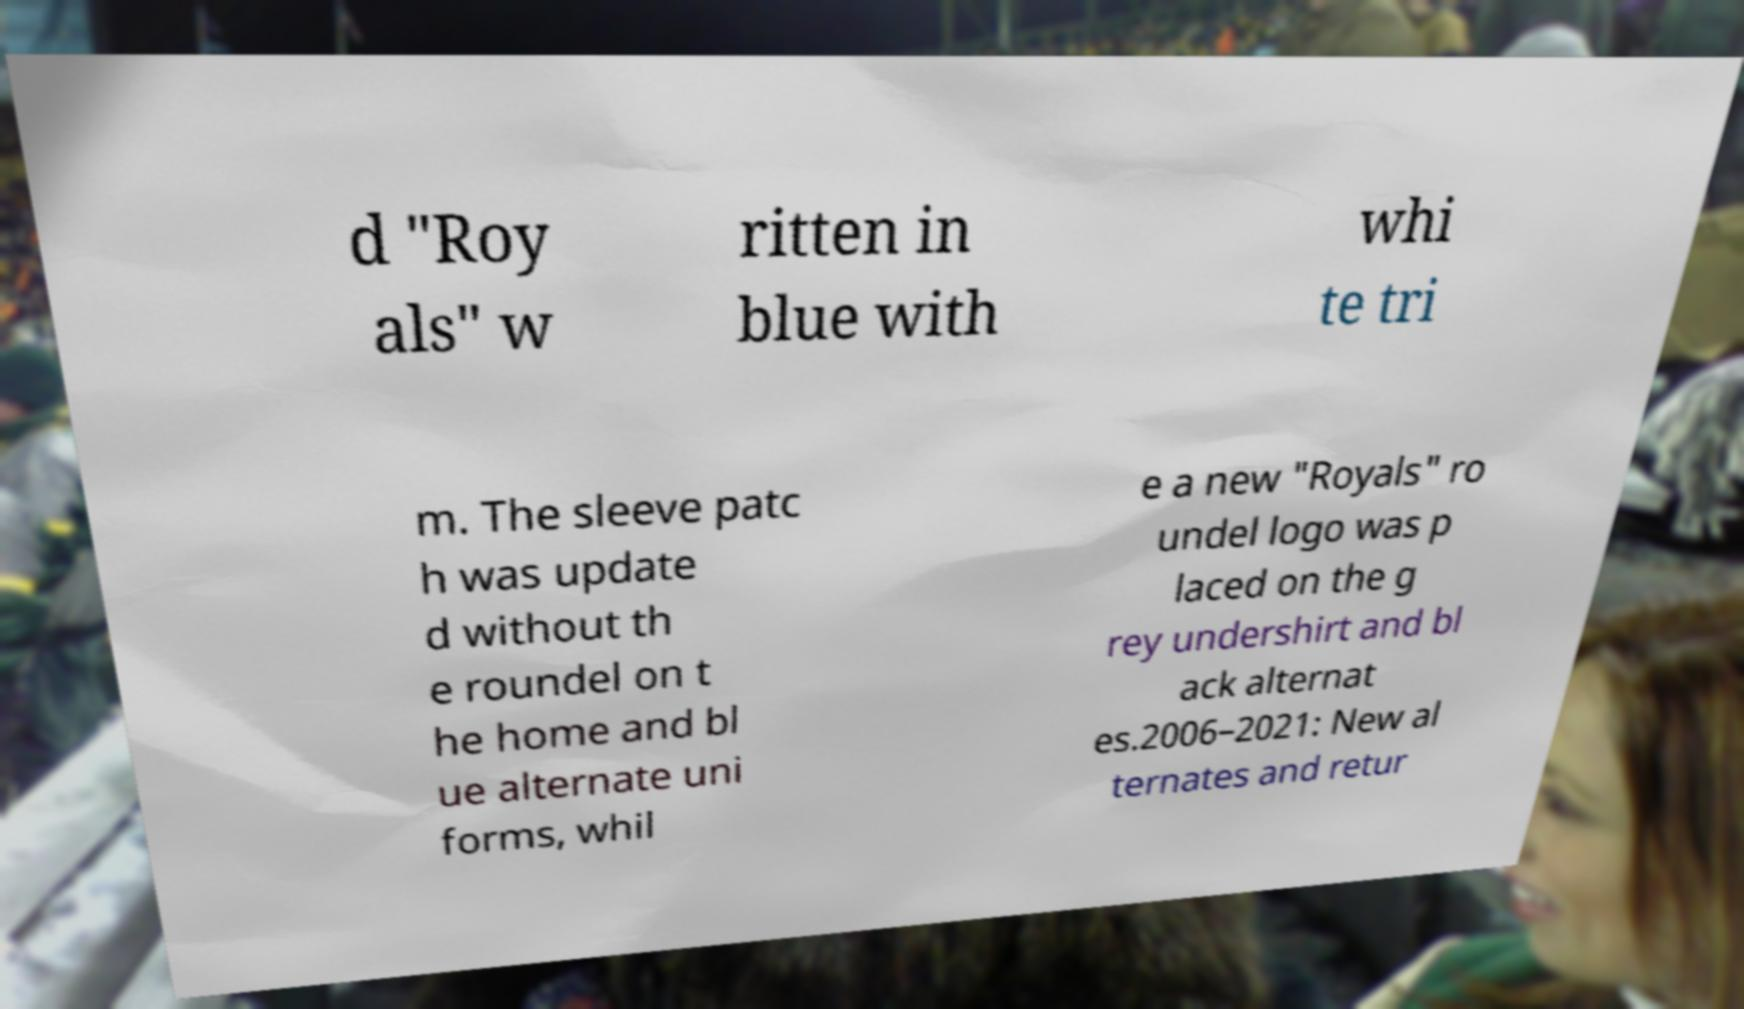Could you extract and type out the text from this image? d "Roy als" w ritten in blue with whi te tri m. The sleeve patc h was update d without th e roundel on t he home and bl ue alternate uni forms, whil e a new "Royals" ro undel logo was p laced on the g rey undershirt and bl ack alternat es.2006–2021: New al ternates and retur 